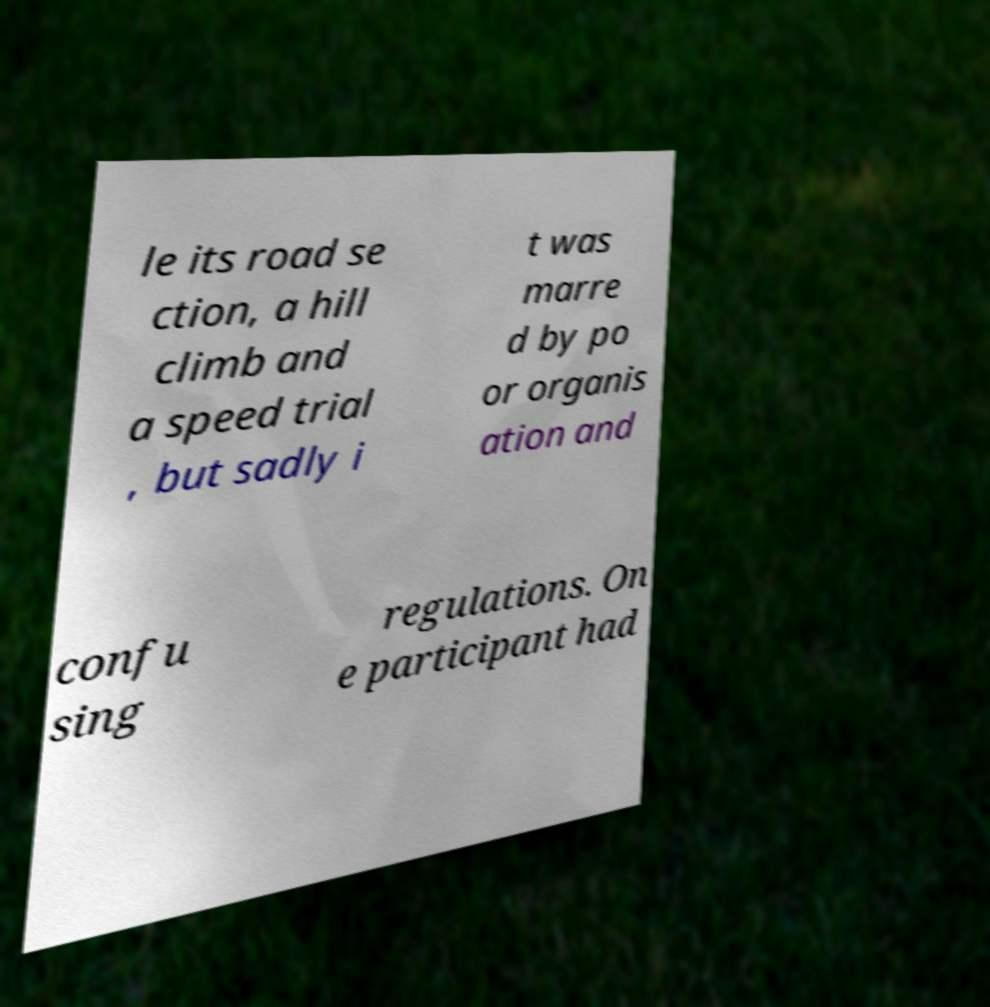Please read and relay the text visible in this image. What does it say? le its road se ction, a hill climb and a speed trial , but sadly i t was marre d by po or organis ation and confu sing regulations. On e participant had 